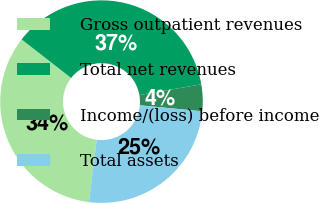<chart> <loc_0><loc_0><loc_500><loc_500><pie_chart><fcel>Gross outpatient revenues<fcel>Total net revenues<fcel>Income/(loss) before income<fcel>Total assets<nl><fcel>33.54%<fcel>36.74%<fcel>4.26%<fcel>25.47%<nl></chart> 